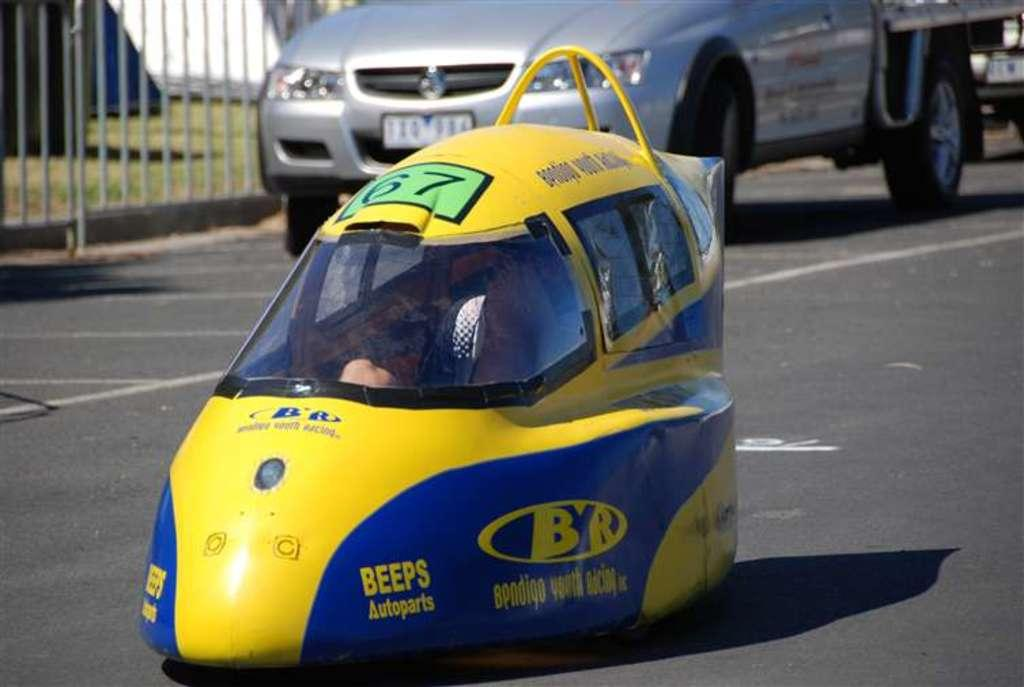<image>
Give a short and clear explanation of the subsequent image. A car with advertising that says Beeps Autoparts on it. 